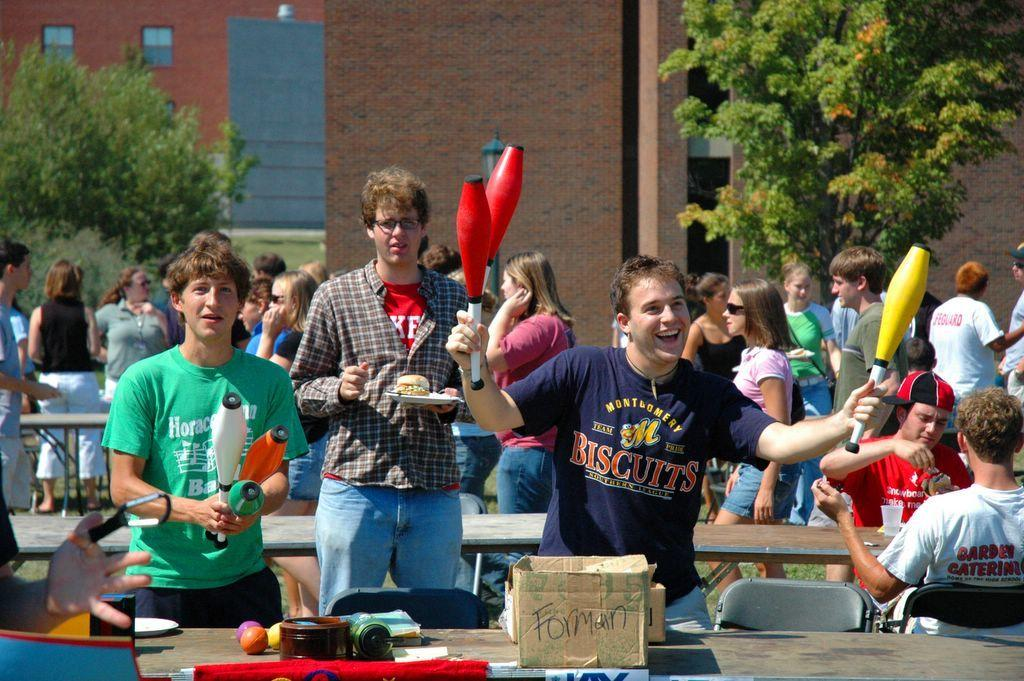<image>
Render a clear and concise summary of the photo. A man wearing a blue t-shirt reading BISCUITS stands in front of a table. 